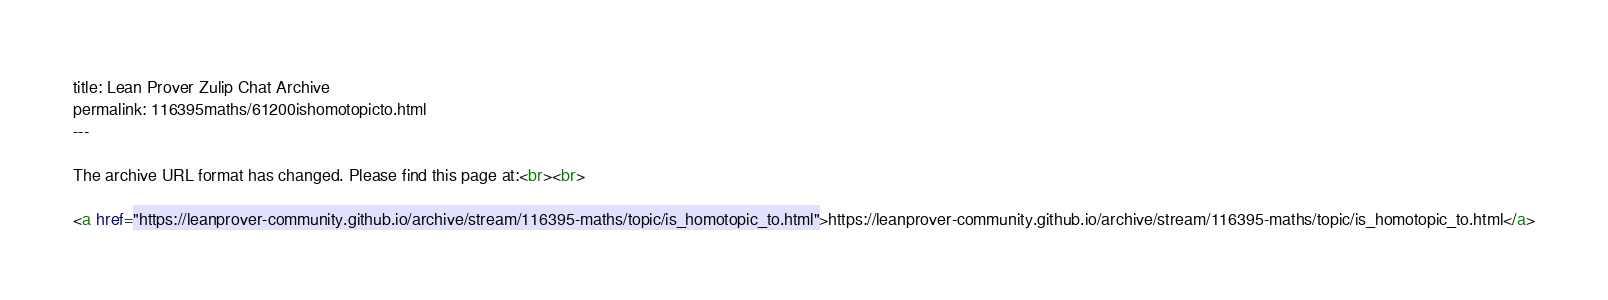Convert code to text. <code><loc_0><loc_0><loc_500><loc_500><_HTML_>title: Lean Prover Zulip Chat Archive
permalink: 116395maths/61200ishomotopicto.html
---

The archive URL format has changed. Please find this page at:<br><br>

<a href="https://leanprover-community.github.io/archive/stream/116395-maths/topic/is_homotopic_to.html">https://leanprover-community.github.io/archive/stream/116395-maths/topic/is_homotopic_to.html</a></code> 